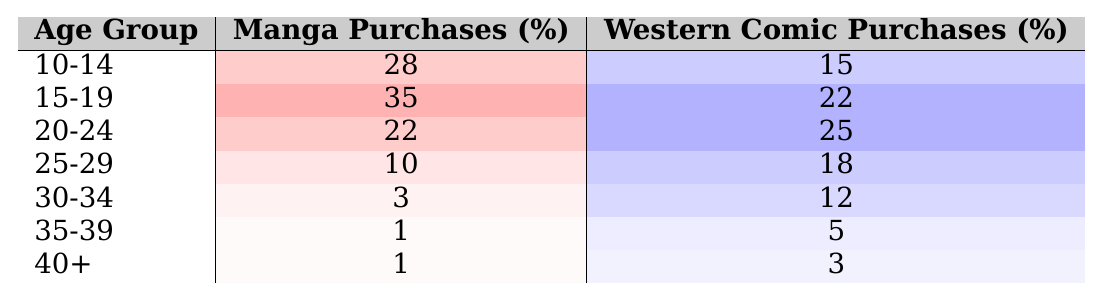What percentage of the 15-19 age group prefers manga over Western comics? According to the table, 35% of the 15-19 age group prefers manga, while 22% prefers Western comics.
Answer: 35% Which age group has the highest percentage of manga purchases? The 15-19 age group has the highest percentage of manga purchases at 35%.
Answer: 15-19 What is the difference in manga purchases between the 10-14 and 20-24 age groups? The 10-14 age group has 28% manga purchases, while the 20-24 age group has 22%. The difference is 28% - 22% = 6%.
Answer: 6% Is it true that the percentage of Western comic purchases increases as the age group increases? From the table, the percentage of Western comic purchases in age groups does seem to increase from 10-14 (15%) to 25-29 (18%) but decreases in older groups. So, the statement is not consistently true.
Answer: No What is the total percentage of manga purchases for age groups 25-29 and 30-34 combined? For age groups 25-29 (10% manga purchases) and 30-34 (3% manga purchases), we add those percentages: 10% + 3% = 13%.
Answer: 13% Which age group has more preference for Western comics than for manga? The 20-24 age group has 25% Western comic purchases, higher than its 22% manga purchases, making it the first group where this occurs.
Answer: 20-24 What is the average percentage of manga purchases across all age groups listed? To find the average, we sum the manga percentages: 28 + 35 + 22 + 10 + 3 + 1 + 1 = 100. There are 7 age groups, so the average is 100/7 = approximately 14.29%.
Answer: 14.29% How do the total percentages of manga purchases compare to Western comic purchases for ages 10-19? For ages 10-14 (28% manga, 15% Western) and 15-19 (35% manga, 22% Western), adding those gives 63% manga and 37% Western. Manga purchases are higher by 26%.
Answer: 26% 